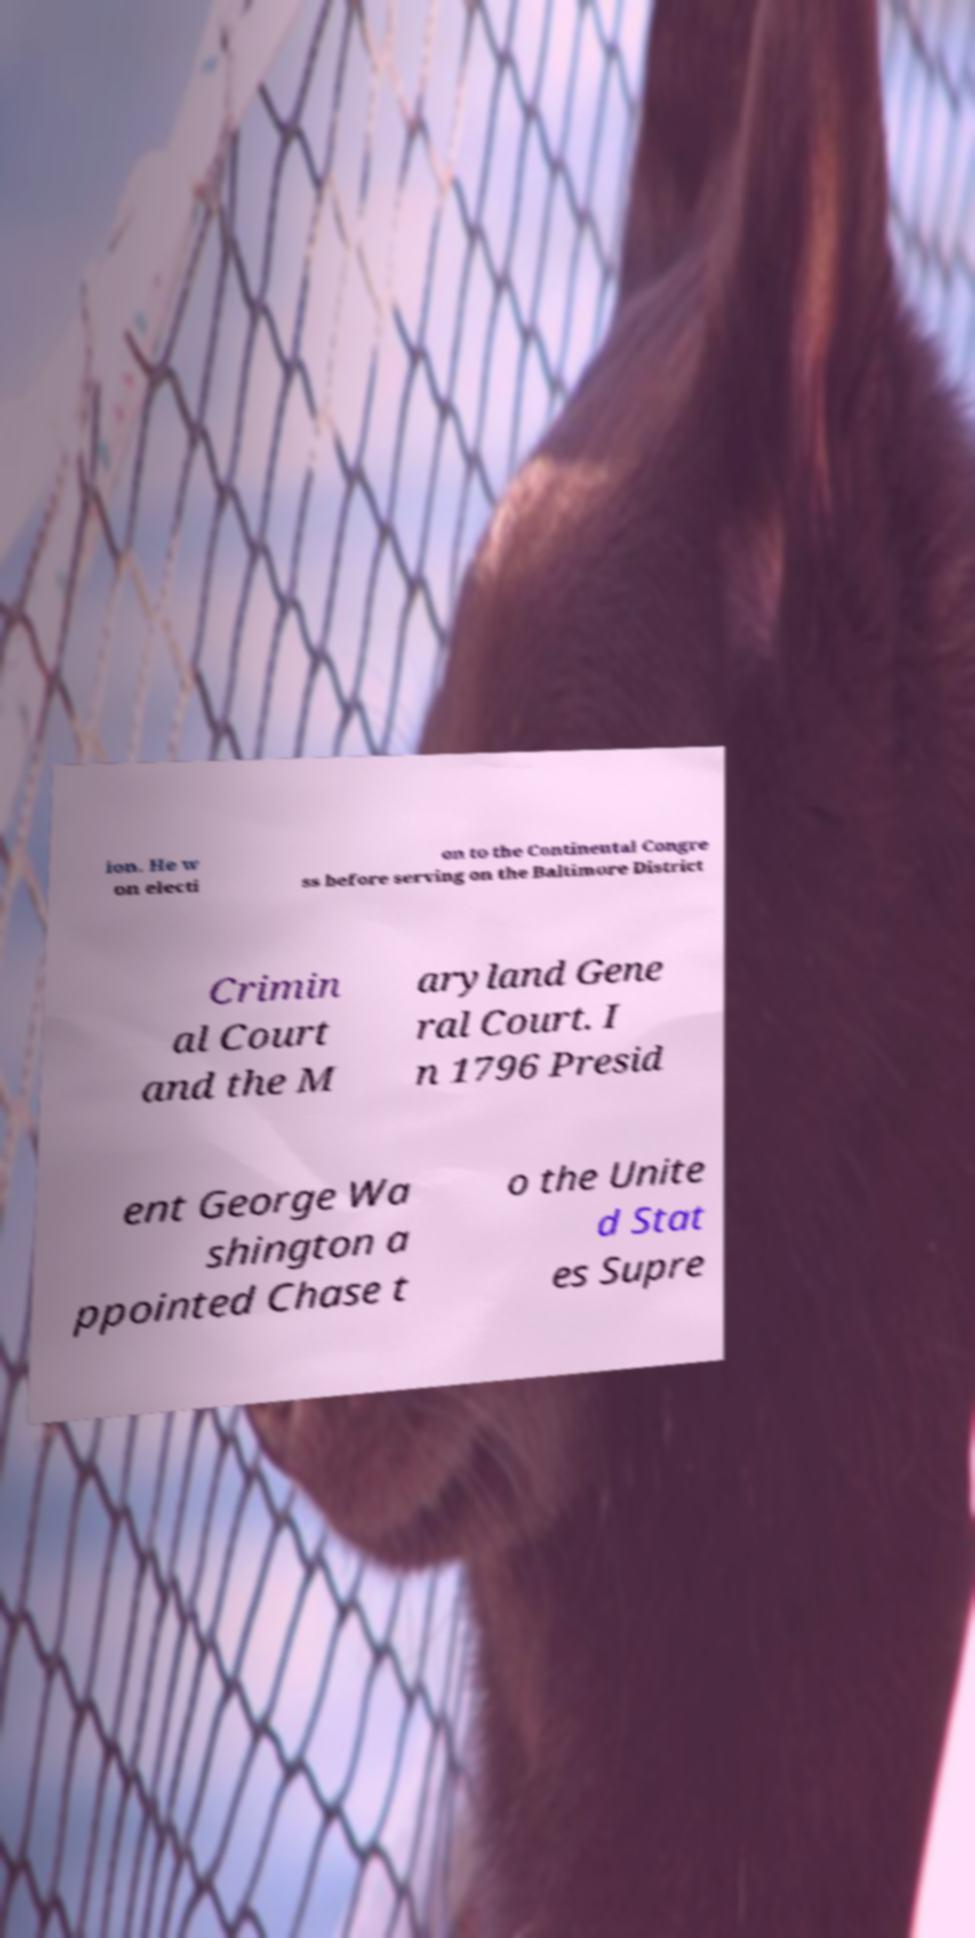Can you accurately transcribe the text from the provided image for me? ion. He w on electi on to the Continental Congre ss before serving on the Baltimore District Crimin al Court and the M aryland Gene ral Court. I n 1796 Presid ent George Wa shington a ppointed Chase t o the Unite d Stat es Supre 